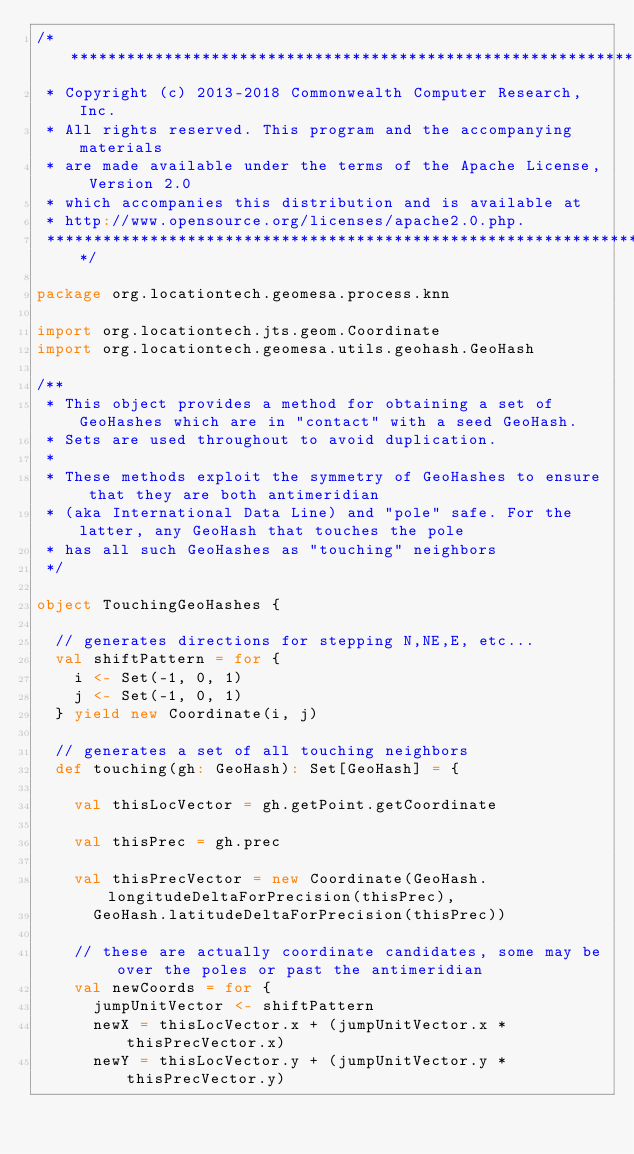<code> <loc_0><loc_0><loc_500><loc_500><_Scala_>/***********************************************************************
 * Copyright (c) 2013-2018 Commonwealth Computer Research, Inc.
 * All rights reserved. This program and the accompanying materials
 * are made available under the terms of the Apache License, Version 2.0
 * which accompanies this distribution and is available at
 * http://www.opensource.org/licenses/apache2.0.php.
 ***********************************************************************/

package org.locationtech.geomesa.process.knn

import org.locationtech.jts.geom.Coordinate
import org.locationtech.geomesa.utils.geohash.GeoHash

/**
 * This object provides a method for obtaining a set of GeoHashes which are in "contact" with a seed GeoHash.
 * Sets are used throughout to avoid duplication.
 *
 * These methods exploit the symmetry of GeoHashes to ensure that they are both antimeridian
 * (aka International Data Line) and "pole" safe. For the latter, any GeoHash that touches the pole
 * has all such GeoHashes as "touching" neighbors
 */

object TouchingGeoHashes {

  // generates directions for stepping N,NE,E, etc...
  val shiftPattern = for {
    i <- Set(-1, 0, 1)
    j <- Set(-1, 0, 1)
  } yield new Coordinate(i, j)

  // generates a set of all touching neighbors
  def touching(gh: GeoHash): Set[GeoHash] = {

    val thisLocVector = gh.getPoint.getCoordinate

    val thisPrec = gh.prec

    val thisPrecVector = new Coordinate(GeoHash.longitudeDeltaForPrecision(thisPrec),
      GeoHash.latitudeDeltaForPrecision(thisPrec))

    // these are actually coordinate candidates, some may be over the poles or past the antimeridian
    val newCoords = for {
      jumpUnitVector <- shiftPattern
      newX = thisLocVector.x + (jumpUnitVector.x * thisPrecVector.x)
      newY = thisLocVector.y + (jumpUnitVector.y * thisPrecVector.y)</code> 